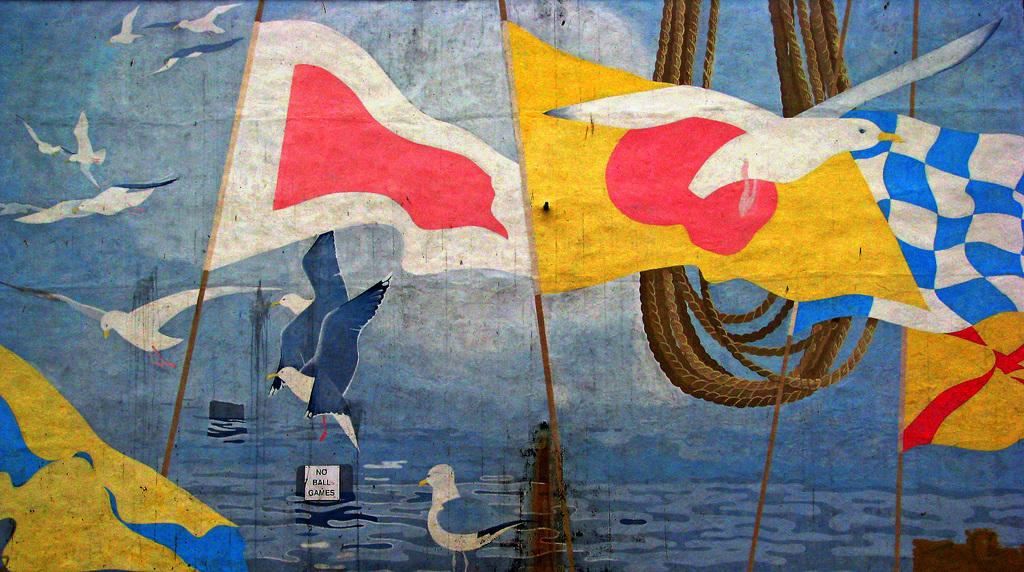What is the main subject of the image? The main subject of the image is a painting. What can be seen in the painting? The painting contains flags, birds, water, and ropes. Are there any other elements in the painting besides the ones mentioned? Yes, there are other unspecified elements in the painting. What type of juice is being squeezed out of the edge of the painting? There is no juice or squeezing action present in the image; it is a painting with various elements, including flags, birds, water, and ropes. 